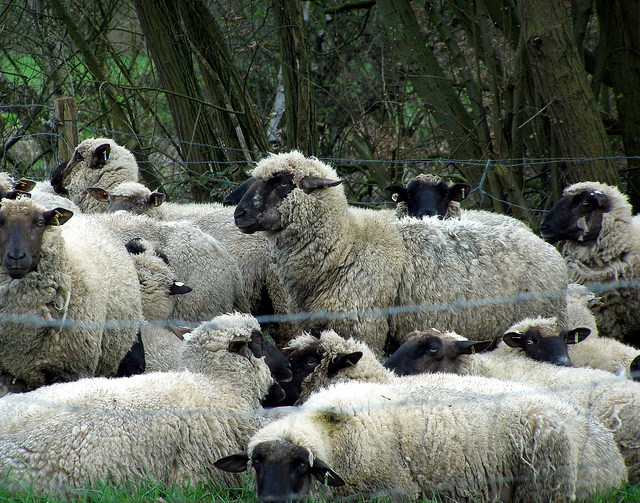Can you describe what's in the image you're seeing? Certainly. The image shows a close-up view of a flock of sheep, clustered tightly together near a fence. Their woolly coats are thick and varying shades of white and gray. In the background, there's dense vegetation including trees, contributing to an overall serene and natural atmosphere. The sheep appear calm and content as they stand close to one another. 